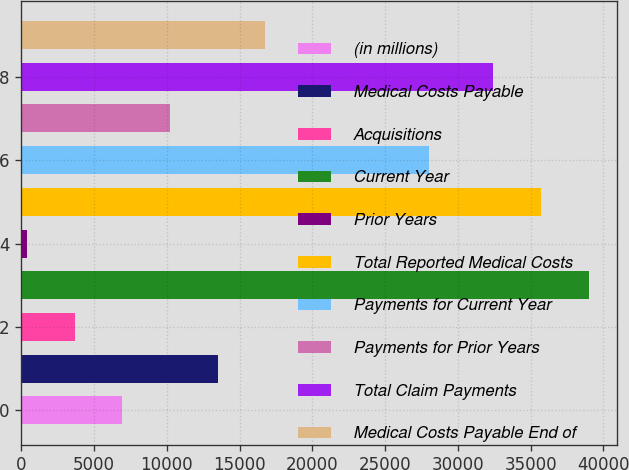Convert chart to OTSL. <chart><loc_0><loc_0><loc_500><loc_500><bar_chart><fcel>(in millions)<fcel>Medical Costs Payable<fcel>Acquisitions<fcel>Current Year<fcel>Prior Years<fcel>Total Reported Medical Costs<fcel>Payments for Current Year<fcel>Payments for Prior Years<fcel>Total Claim Payments<fcel>Medical Costs Payable End of<nl><fcel>6945<fcel>13490<fcel>3672.5<fcel>38978<fcel>400<fcel>35705.5<fcel>27985<fcel>10217.5<fcel>32433<fcel>16762.5<nl></chart> 